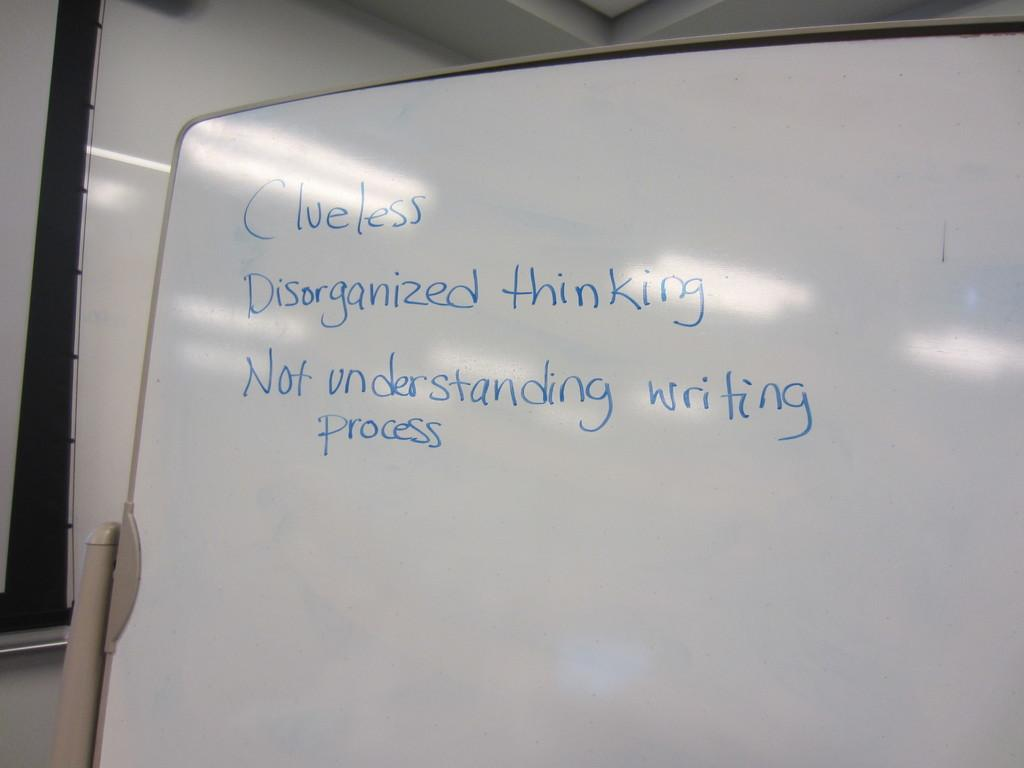<image>
Summarize the visual content of the image. A whiteboard that has writing on it starting with the work Clueless. 